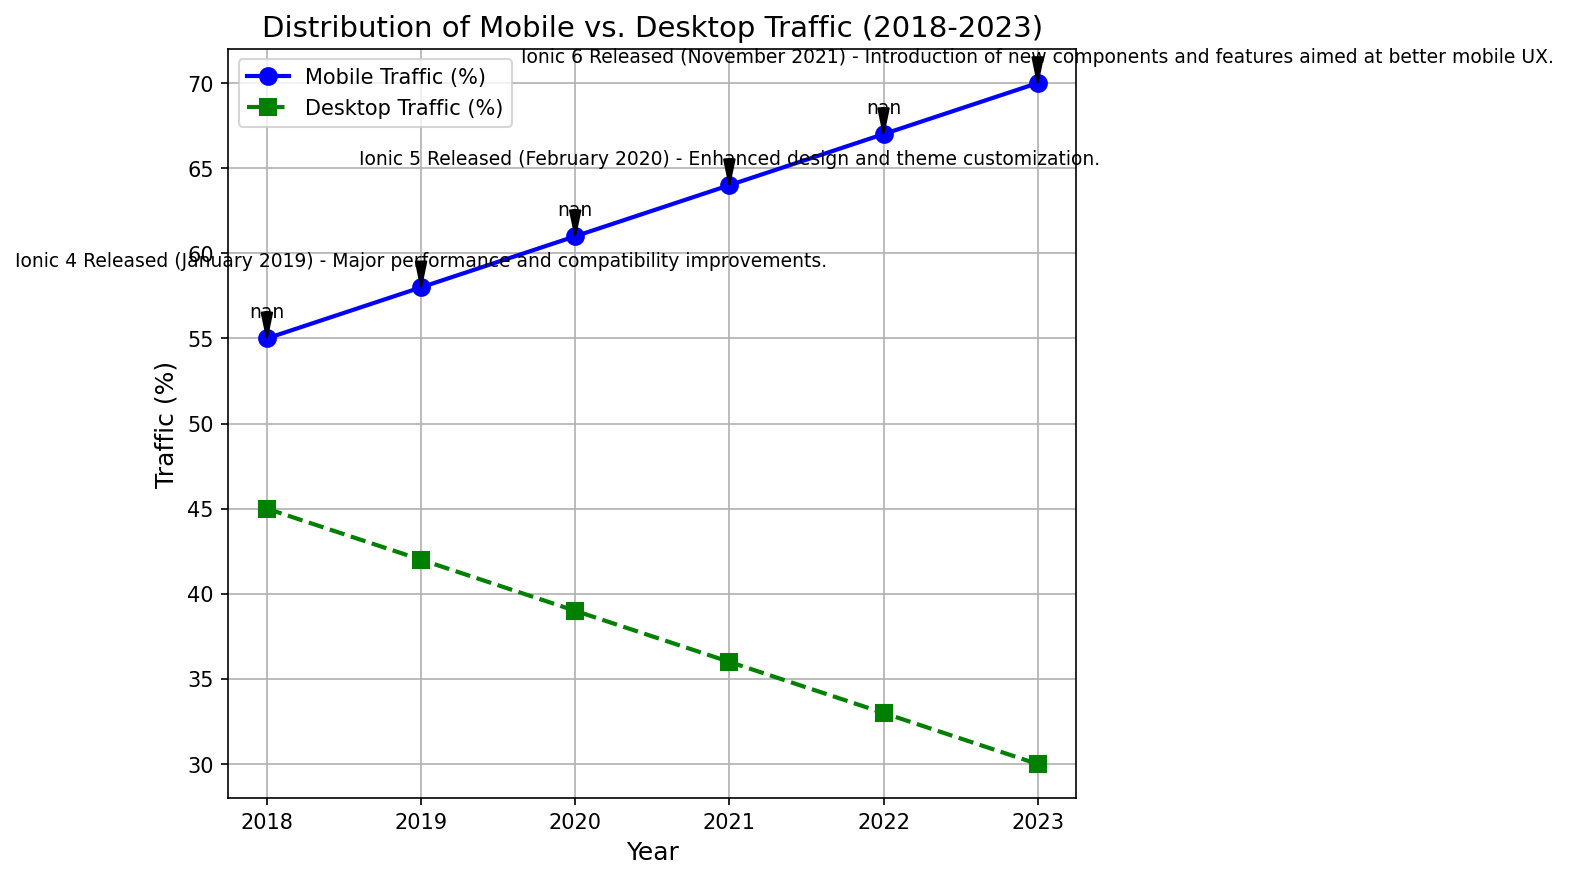What year shows the highest percentage of mobile traffic? To find the year with the highest mobile traffic, we look at the line for mobile traffic (blue) and identify the highest point. According to the figure, the highest point is in the year 2023, with a mobile traffic percentage of 70%.
Answer: 2023 Which year had the closest mobile and desktop traffic percentages? To determine the closest percentages, we need to compare the blue and green lines and identify where their values are closest. The year 2018 shows mobile traffic at 55% and desktop traffic at 45%, which is the smallest difference.
Answer: 2018 How did the release of Ionic 5 in February 2020 seem to impact mobile traffic trends? We can see from the annotations and the figure that Ionic 5 was released in early 2020. Mobile traffic increased from 61% in 2020 to 64% in 2021, suggesting a continued upward trend, possibly influenced by the new release.
Answer: It increased What is the difference in mobile traffic percentage between 2019 and 2023? To find the difference, subtract the 2019 mobile traffic percentage (58%) from the 2023 mobile traffic percentage (70%). The calculation is 70% - 58% = 12%.
Answer: 12% By how much has desktop traffic decreased from 2018 to 2023? To determine the decrease, subtract the 2023 desktop traffic percentage (30%) from the 2018 desktop traffic percentage (45%). The calculation is 45% - 30% = 15%.
Answer: 15% Which release corresponds with the largest single-year increase in mobile traffic percentage? We need to look at the annotations and the corresponding year-to-year increases in mobile traffic. The release of Ionic 4 in January 2019 corresponds to an increase from 2018 (55%) to 2019 (58%), which is the largest single-year increase of 3%.
Answer: Ionic 4 What was the trend in desktop traffic between 2020 and 2022? Observing the green line from 2020 to 2022, the desktop traffic decreases steadily each year: from 39% in 2020, to 36% in 2021, and then to 33% in 2022.
Answer: It decreased Which year shows the highest overall decline in desktop traffic compared to the previous year? We need to compare the yearly declines: 
- 2018 to 2019: 45% to 42% (3% decline)
- 2019 to 2020: 42% to 39% (3% decline)
- 2020 to 2021: 39% to 36% (3% decline)
- 2021 to 2022: 36% to 33% (3% decline)
- 2022 to 2023: 33% to 30% (3% decline)
All these decreases are equal, with each showing a decline of 3%.
Answer: All years show an equal decline What percentage increase in mobile traffic is observed from the release of Ionic 6 to 2023? Ionic 6 was released in November 2021, and in the following year, mobile traffic was 67%. In 2023, mobile traffic increased to 70%. The percentage increase from 67% to 70% is calculated as 70% - 67% = 3%.
Answer: 3% 